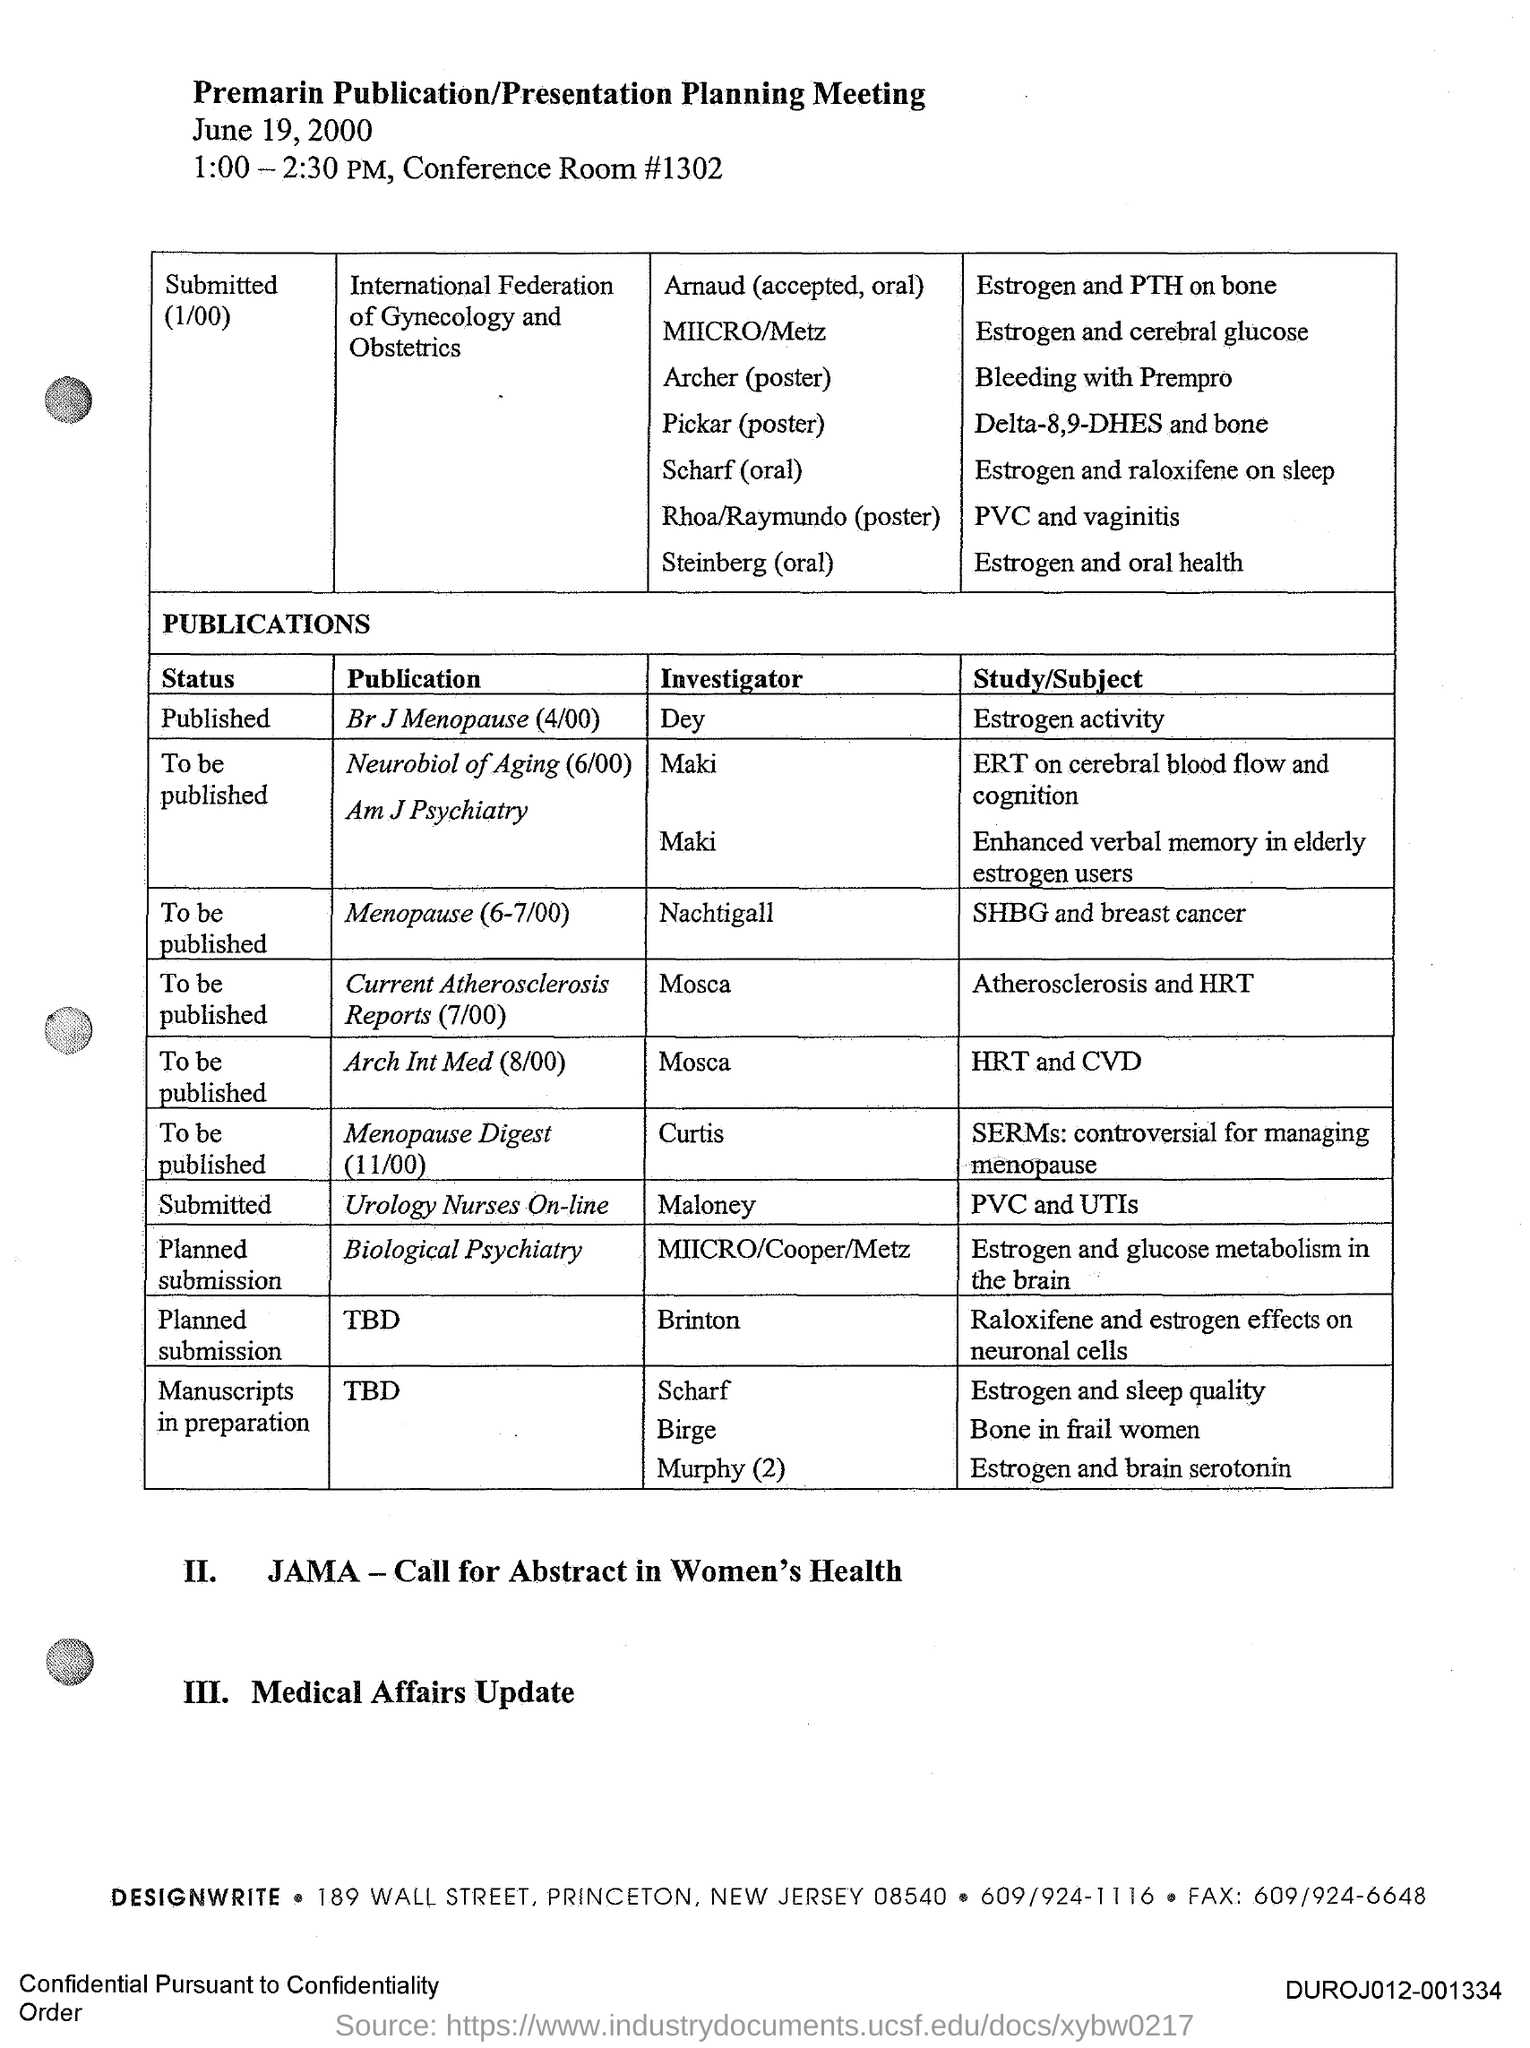List a handful of essential elements in this visual. The investigator for the publication in the British Journal of Menopause (April 2000) is Dey. The title of the document is "Premarin Publication/Presentation Planning Meeting. The investigator for the publication "Menopause" (6-7/100) is Nachtigall. 